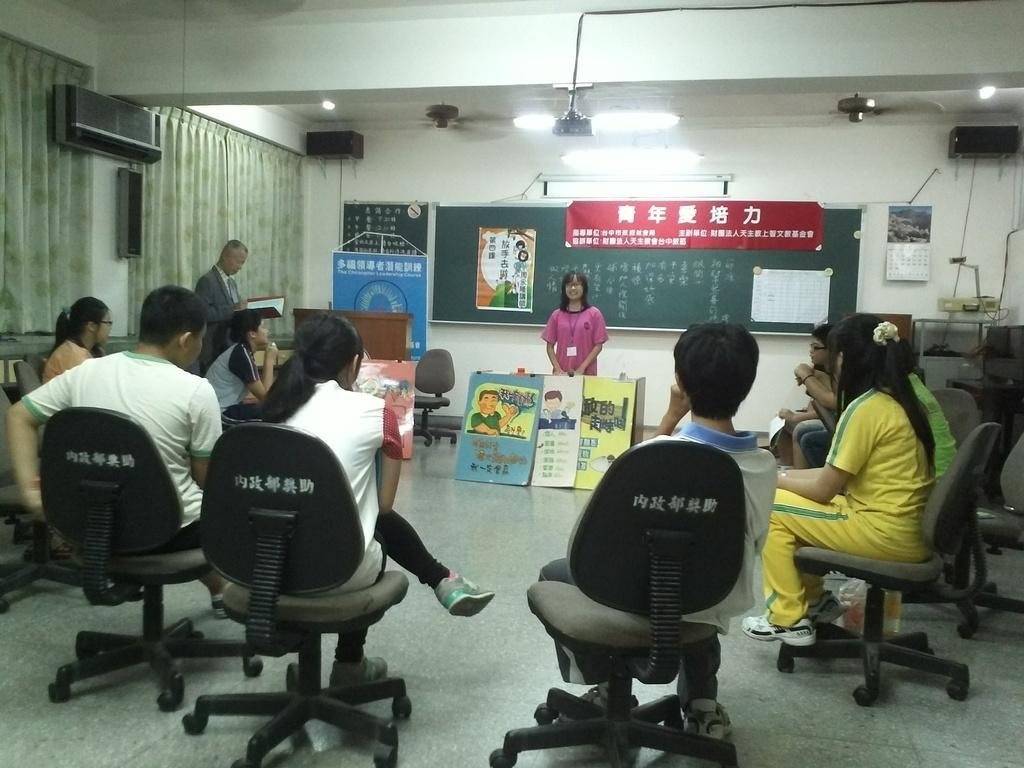What are the people in the image doing? There is a group of people sitting on chairs in the image. Can you describe the woman in the image? There is a woman standing in the image. What is located at the back side of the image? There is a board at the back side of the image. What type of window treatment is present in the image? There are curtains in the image. What type of snake can be seen slithering on the board in the image? There is no snake present in the image; it only features a group of people sitting on chairs, a woman standing, a board, and curtains. 